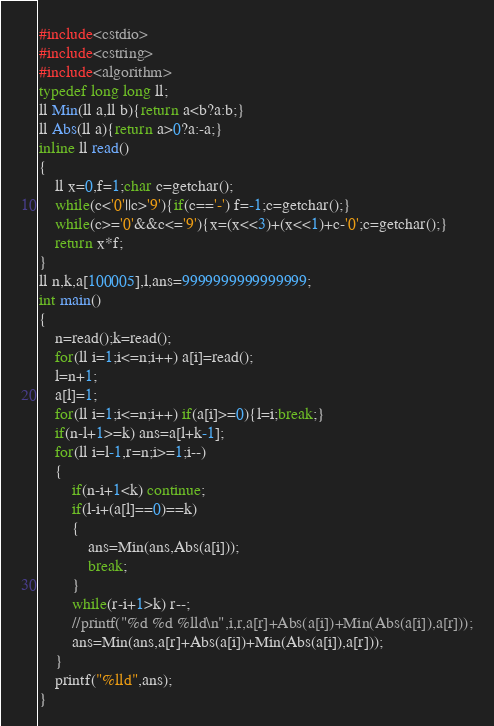<code> <loc_0><loc_0><loc_500><loc_500><_C++_>#include<cstdio>
#include<cstring>
#include<algorithm>
typedef long long ll;
ll Min(ll a,ll b){return a<b?a:b;}
ll Abs(ll a){return a>0?a:-a;}
inline ll read()
{
	ll x=0,f=1;char c=getchar();
	while(c<'0'||c>'9'){if(c=='-') f=-1;c=getchar();}
	while(c>='0'&&c<='9'){x=(x<<3)+(x<<1)+c-'0';c=getchar();}
	return x*f;
}
ll n,k,a[100005],l,ans=9999999999999999;
int main()
{
	n=read();k=read();
	for(ll i=1;i<=n;i++) a[i]=read();
	l=n+1;
	a[l]=1;
	for(ll i=1;i<=n;i++) if(a[i]>=0){l=i;break;}
	if(n-l+1>=k) ans=a[l+k-1];
	for(ll i=l-1,r=n;i>=1;i--)
	{
		if(n-i+1<k) continue;
		if(l-i+(a[l]==0)==k)
		{
			ans=Min(ans,Abs(a[i]));
			break;
		}
		while(r-i+1>k) r--;
		//printf("%d %d %lld\n",i,r,a[r]+Abs(a[i])+Min(Abs(a[i]),a[r]));
		ans=Min(ans,a[r]+Abs(a[i])+Min(Abs(a[i]),a[r]));
	}
	printf("%lld",ans);
}</code> 